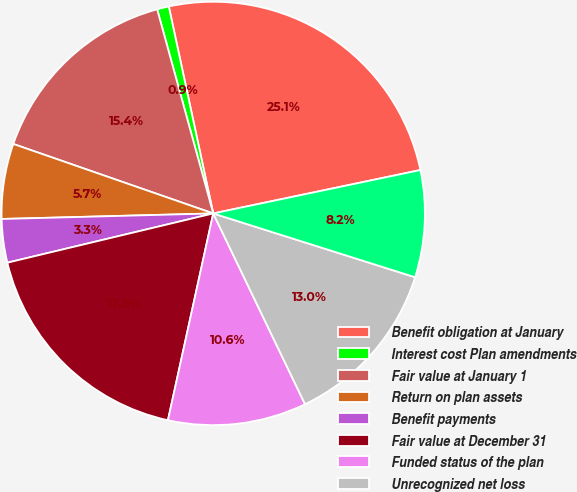Convert chart to OTSL. <chart><loc_0><loc_0><loc_500><loc_500><pie_chart><fcel>Benefit obligation at January<fcel>Interest cost Plan amendments<fcel>Fair value at January 1<fcel>Return on plan assets<fcel>Benefit payments<fcel>Fair value at December 31<fcel>Funded status of the plan<fcel>Unrecognized net loss<fcel>Prepaid (accrued) pension cost<nl><fcel>25.08%<fcel>0.9%<fcel>15.41%<fcel>5.74%<fcel>3.32%<fcel>17.83%<fcel>10.57%<fcel>12.99%<fcel>8.16%<nl></chart> 